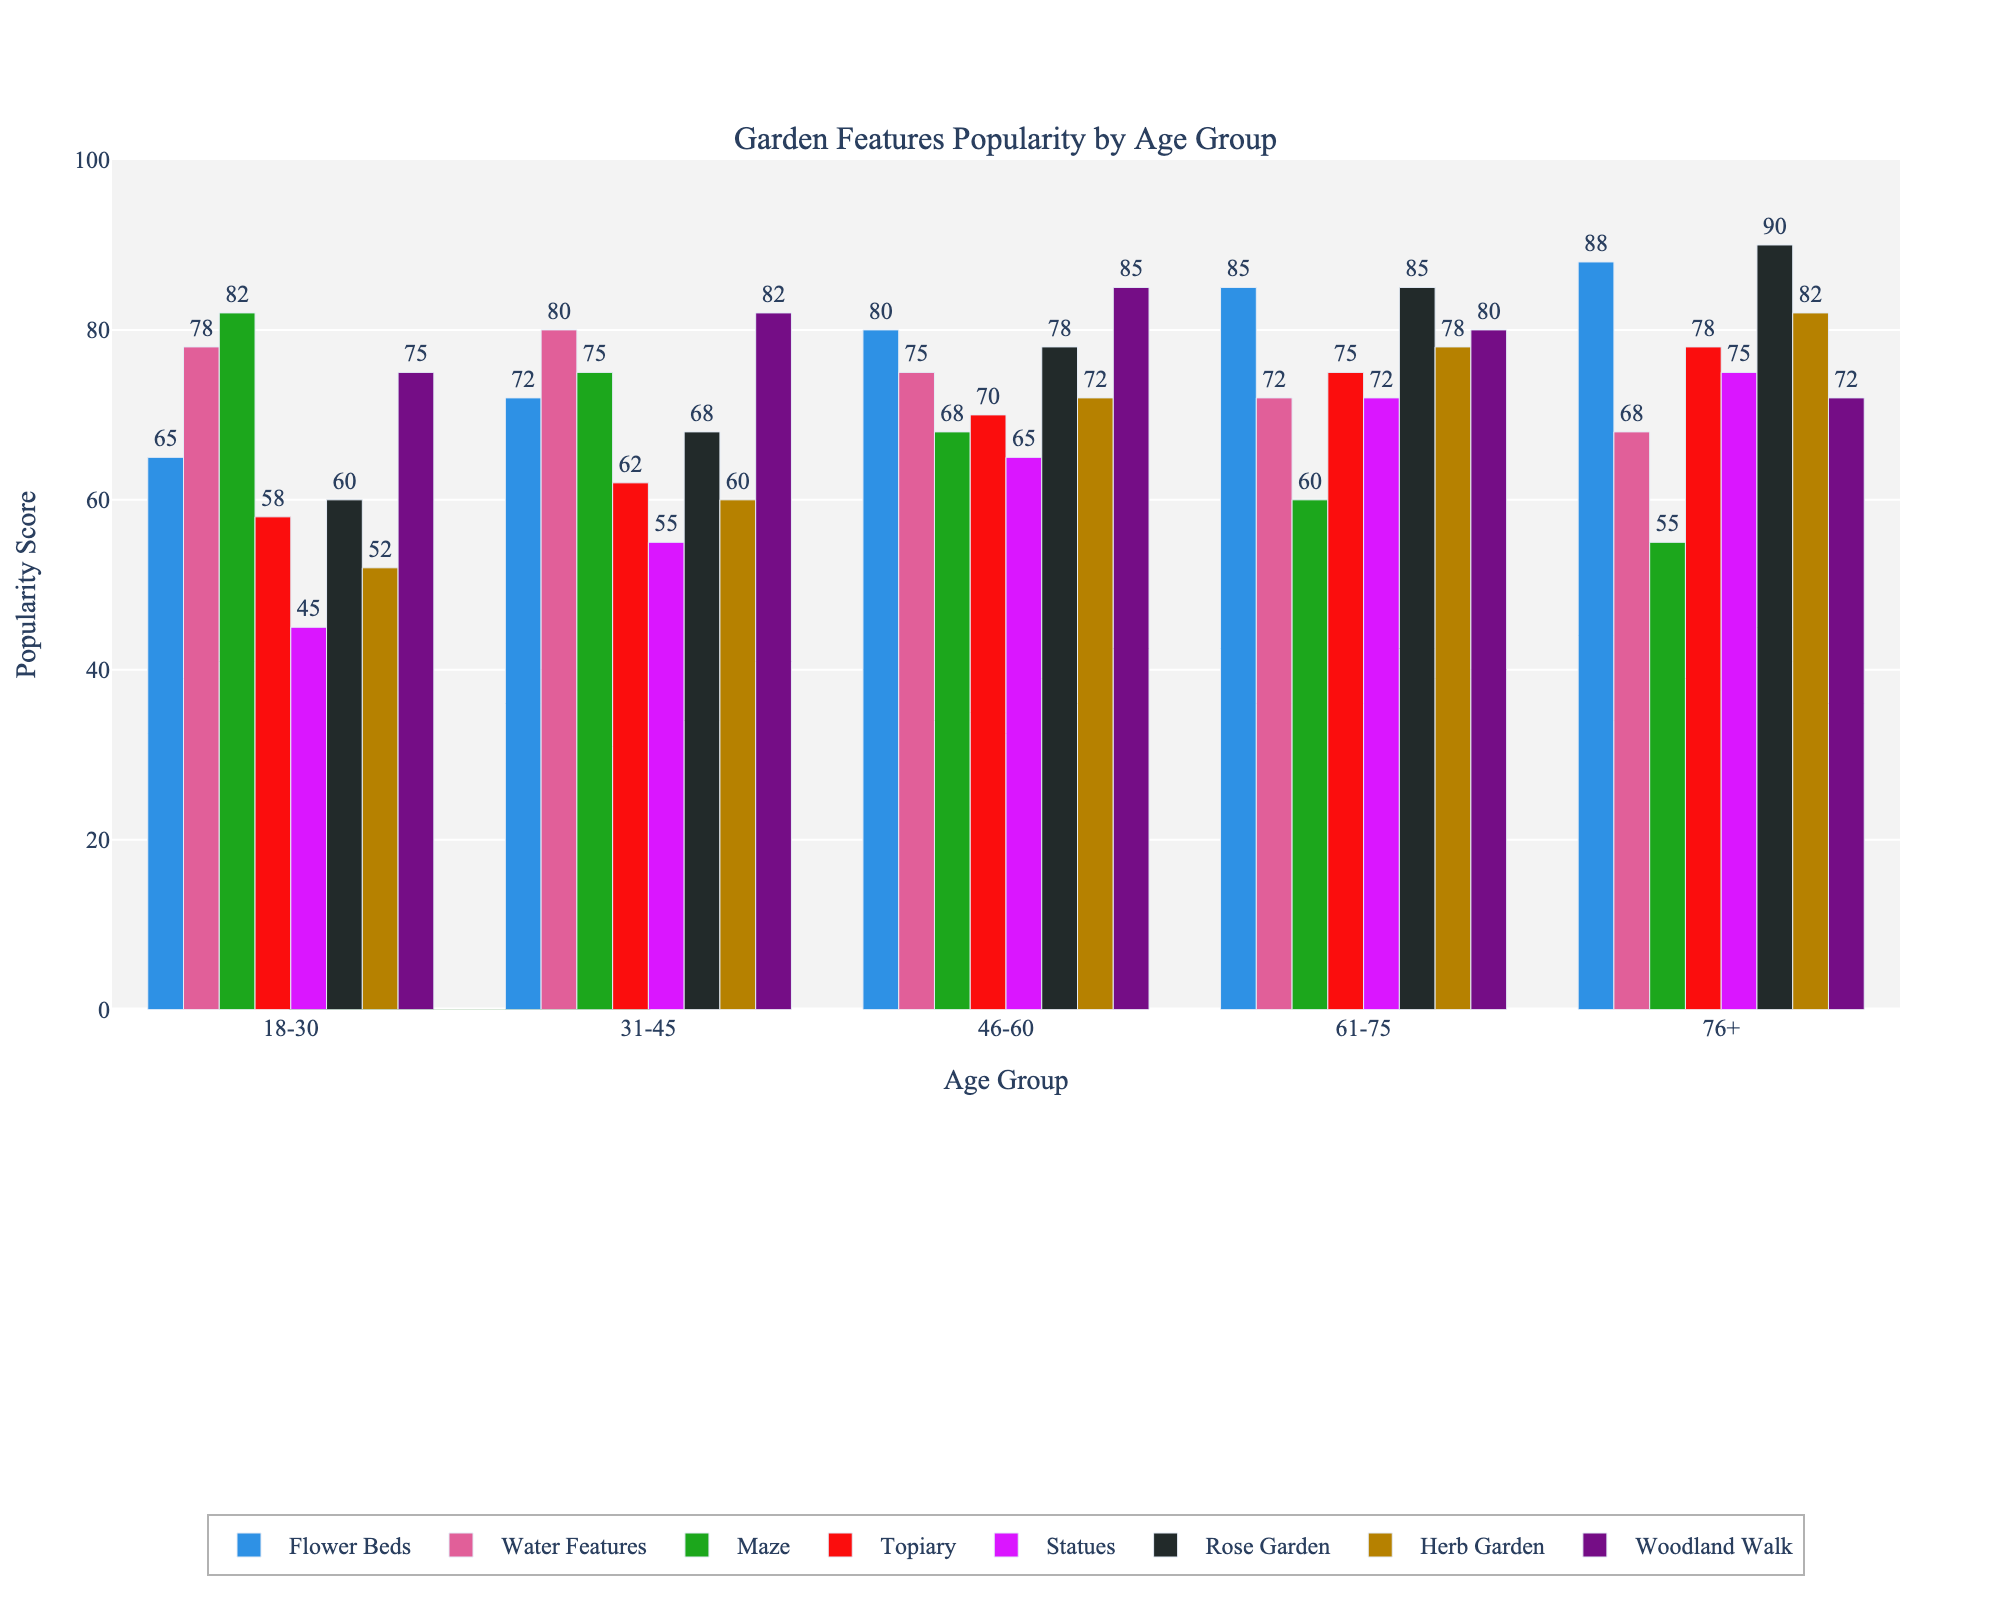What's the most popular garden feature among visitors aged 18-30? For the age group 18-30, the values for each garden feature have been examined. The highest value in this group is for the Maze at 82.
Answer: Maze How does the popularity of Water Features differ between the 18-30 and 76+ age groups? For the 18-30 age group, Water Features have a popularity score of 78. For the 76+ age group, the score is 68. The difference is calculated as 78 - 68 = 10.
Answer: 10 Which garden feature is least popular among visitors aged 76+? In the age group 76+, the smallest value is 55 for the Maze.
Answer: Maze Are Flower Beds more popular among visitors aged 76+ compared to those aged 18-30? By comparing the values, Flower Beds in the 18-30 age group have a score of 65, while in the 76+ age group, it has a score of 88. Since 88 > 65, Flower Beds are more popular among the 76+ group.
Answer: Yes Which two garden features are equally popular among visitors aged 31-45? For the age group 31-45, both Water Features and Woodland Walk have a score of 82. This indicates they are equally popular.
Answer: Water Features and Woodland Walk What is the average popularity score of the Herb Garden across all age groups? To find the average, sum the popularity scores of the Herb Garden for all age groups: 52 (18-30) + 60 (31-45) + 72 (46-60) + 78 (61-75) + 82 (76+). The sum is 344. Now, divide by the number of age groups, which is 5. Therefore, 344 / 5 = 68.8.
Answer: 68.8 Which age group has the highest preference for the Rose Garden? By examining the values for the Rose Garden across all age groups, the highest value is 90 in the 76+ age group.
Answer: 76+ Is the Woodland Walk more popular among visitors aged 61-75 compared to visitors aged 46-60? Comparing the popularity scores: 80 for age 61-75 and 85 for age 46-60. Since 80 < 85, the Woodland Walk is more popular among the 46-60 age group.
Answer: No Which garden feature shows a consistent increase in popularity with increasing age groups? By examining all the features across ascending age groups, the Flower Beds and Rose Garden features have a consistent increase in popularity scores as the age groups progress from 18-30 to 76+.
Answer: Flower Beds and Rose Garden 